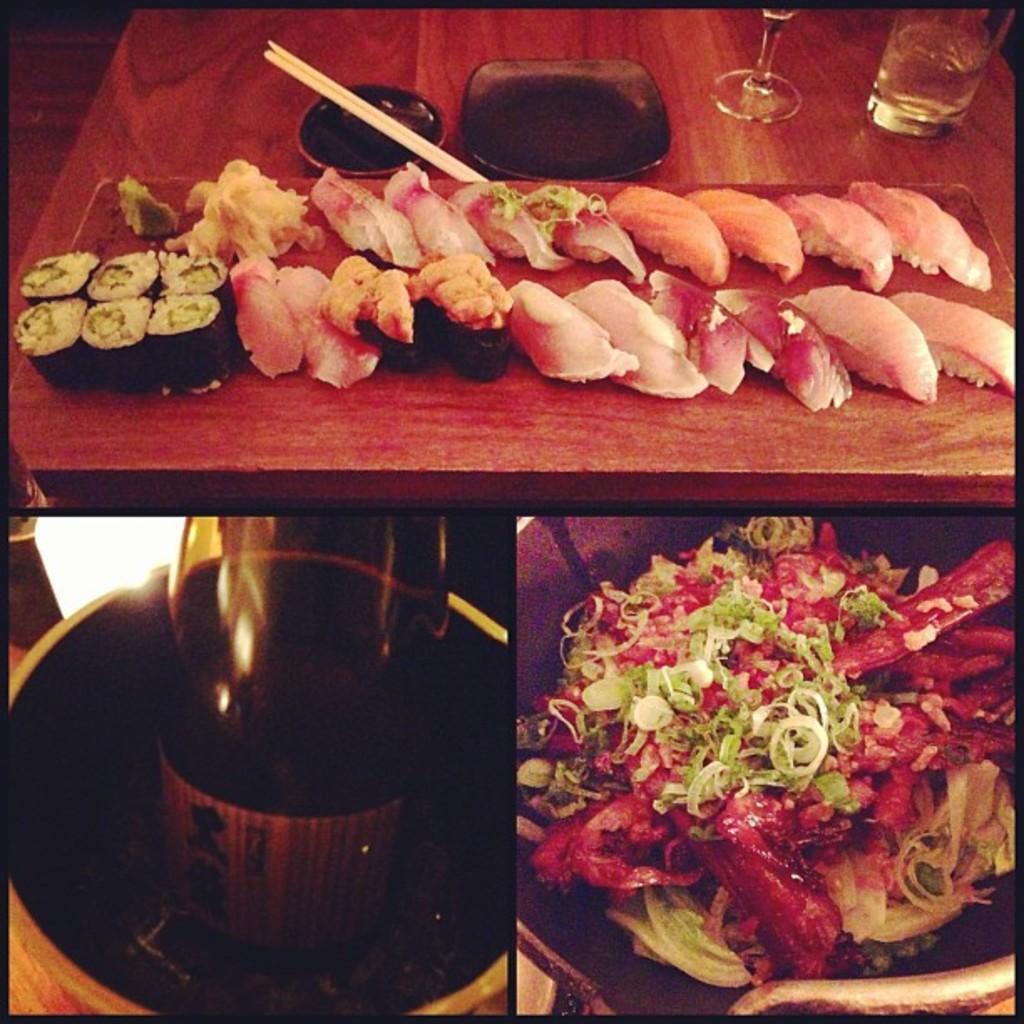Could you give a brief overview of what you see in this image? This is a collage image and the top and the right image contains of food and the left bottom image consists of bottle in the top image we can see chopsticks,glass and plate 